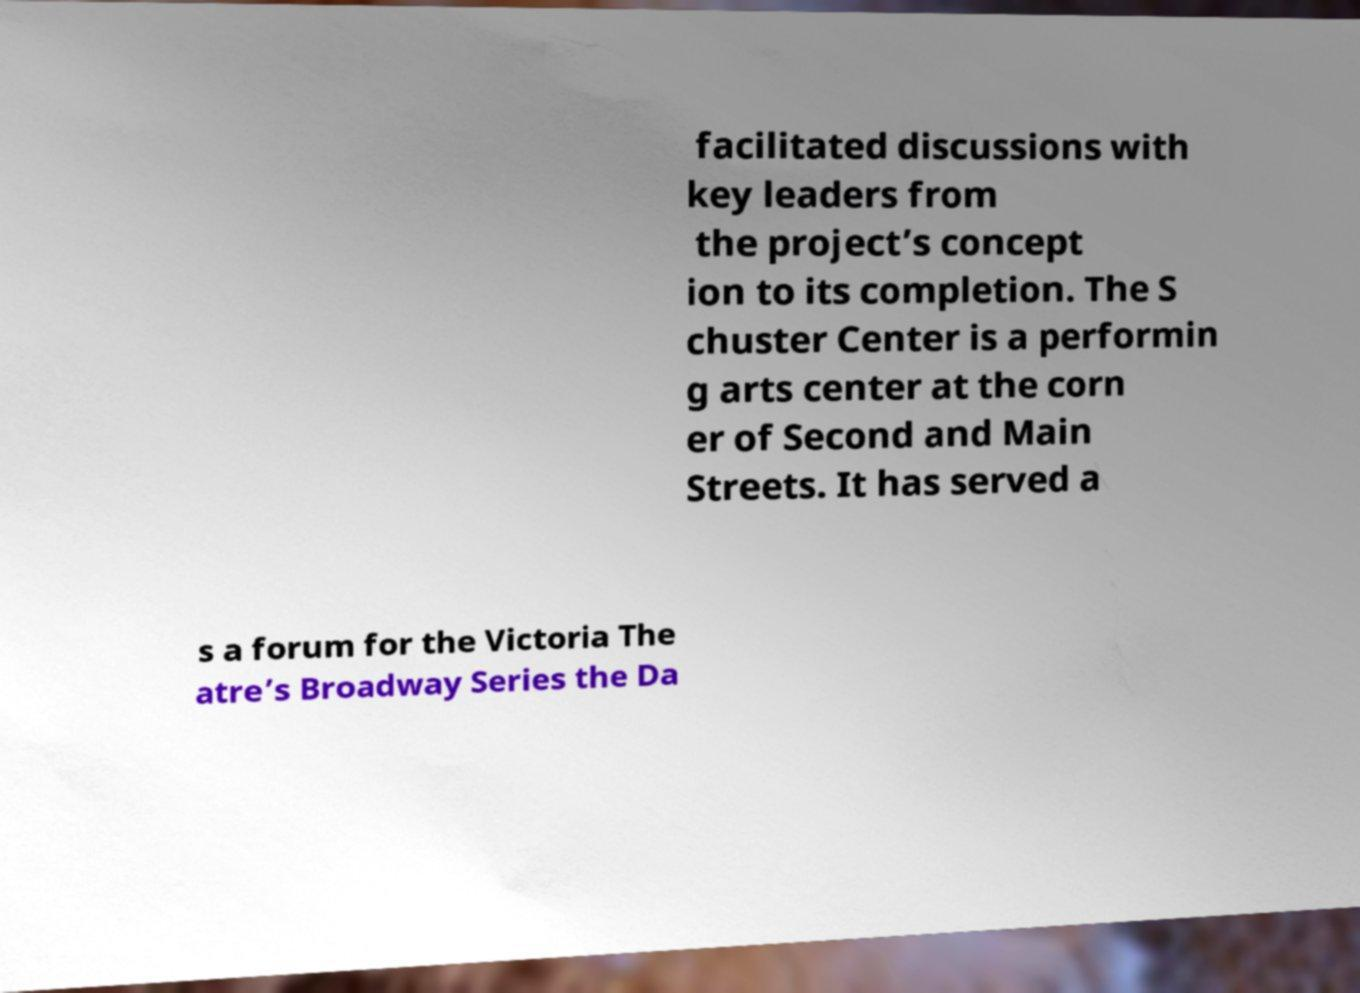Could you assist in decoding the text presented in this image and type it out clearly? facilitated discussions with key leaders from the project’s concept ion to its completion. The S chuster Center is a performin g arts center at the corn er of Second and Main Streets. It has served a s a forum for the Victoria The atre’s Broadway Series the Da 